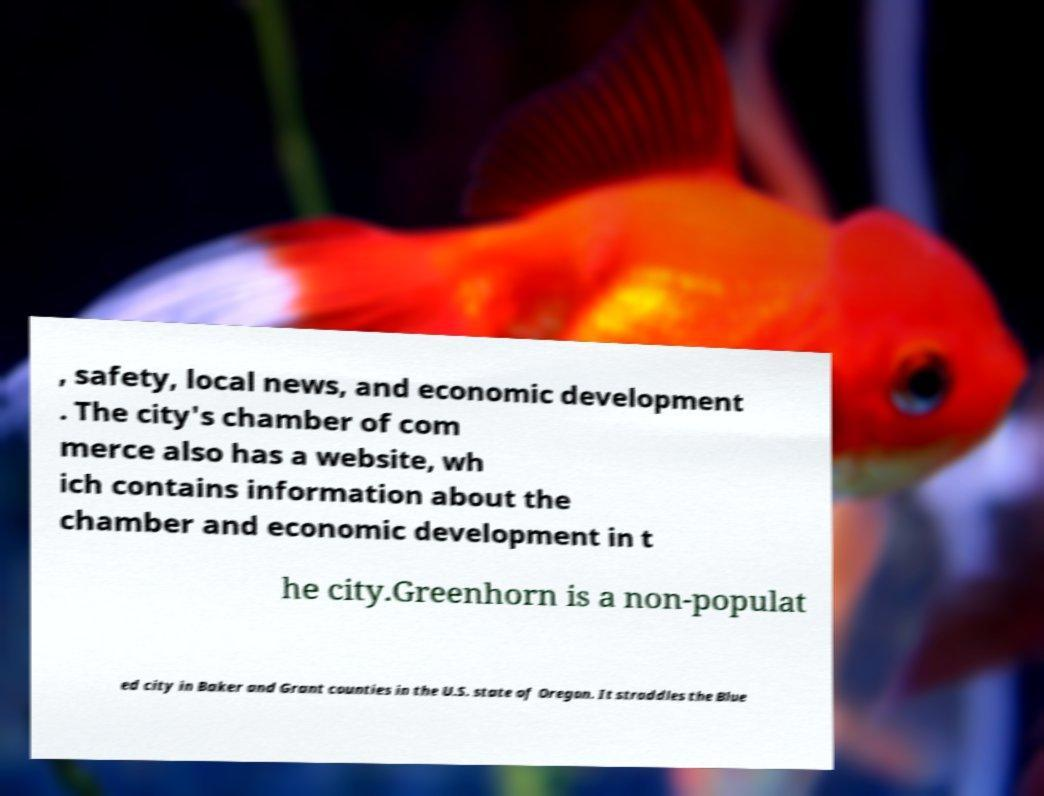Can you read and provide the text displayed in the image?This photo seems to have some interesting text. Can you extract and type it out for me? , safety, local news, and economic development . The city's chamber of com merce also has a website, wh ich contains information about the chamber and economic development in t he city.Greenhorn is a non-populat ed city in Baker and Grant counties in the U.S. state of Oregon. It straddles the Blue 